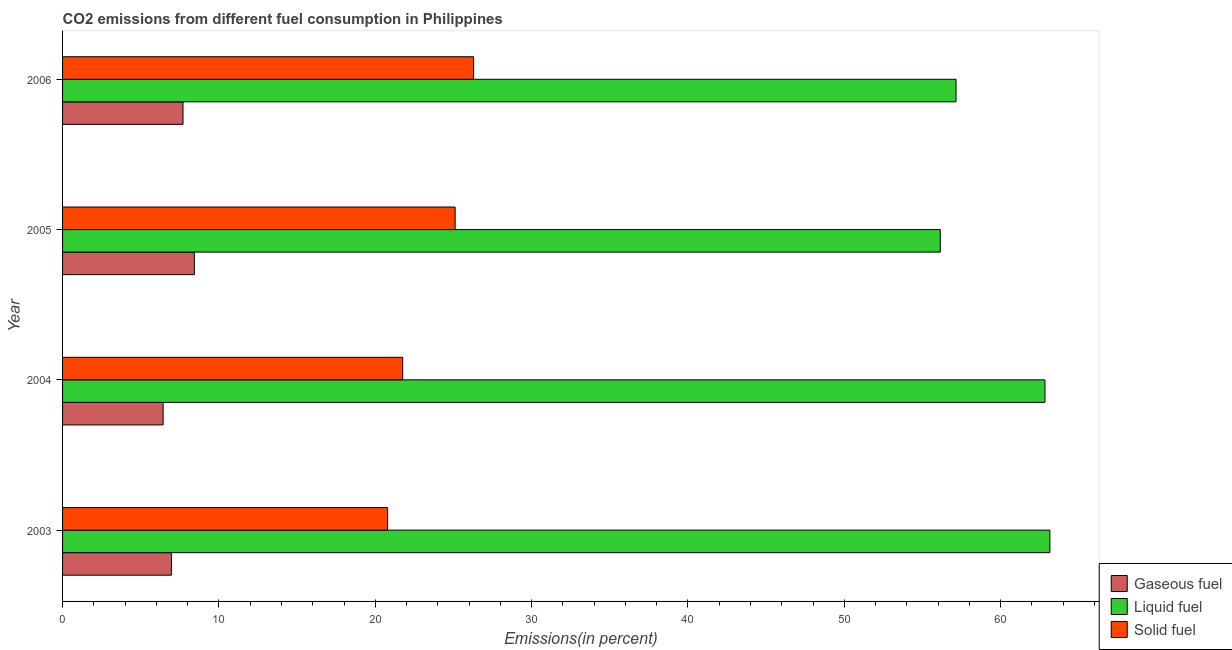How many different coloured bars are there?
Provide a short and direct response. 3. What is the percentage of solid fuel emission in 2004?
Give a very brief answer. 21.75. Across all years, what is the maximum percentage of solid fuel emission?
Keep it short and to the point. 26.29. Across all years, what is the minimum percentage of solid fuel emission?
Provide a succinct answer. 20.79. What is the total percentage of liquid fuel emission in the graph?
Your answer should be compact. 239.26. What is the difference between the percentage of gaseous fuel emission in 2005 and that in 2006?
Your response must be concise. 0.72. What is the difference between the percentage of liquid fuel emission in 2005 and the percentage of solid fuel emission in 2003?
Ensure brevity in your answer.  35.35. What is the average percentage of solid fuel emission per year?
Give a very brief answer. 23.48. In the year 2006, what is the difference between the percentage of gaseous fuel emission and percentage of solid fuel emission?
Your answer should be very brief. -18.59. What is the ratio of the percentage of gaseous fuel emission in 2004 to that in 2005?
Give a very brief answer. 0.76. What is the difference between the highest and the second highest percentage of solid fuel emission?
Give a very brief answer. 1.18. In how many years, is the percentage of liquid fuel emission greater than the average percentage of liquid fuel emission taken over all years?
Keep it short and to the point. 2. Is the sum of the percentage of liquid fuel emission in 2003 and 2005 greater than the maximum percentage of solid fuel emission across all years?
Offer a very short reply. Yes. What does the 3rd bar from the top in 2005 represents?
Ensure brevity in your answer.  Gaseous fuel. What does the 2nd bar from the bottom in 2006 represents?
Keep it short and to the point. Liquid fuel. Is it the case that in every year, the sum of the percentage of gaseous fuel emission and percentage of liquid fuel emission is greater than the percentage of solid fuel emission?
Offer a terse response. Yes. Are all the bars in the graph horizontal?
Provide a succinct answer. Yes. What is the difference between two consecutive major ticks on the X-axis?
Your answer should be very brief. 10. Does the graph contain any zero values?
Your answer should be very brief. No. How are the legend labels stacked?
Keep it short and to the point. Vertical. What is the title of the graph?
Give a very brief answer. CO2 emissions from different fuel consumption in Philippines. What is the label or title of the X-axis?
Offer a terse response. Emissions(in percent). What is the Emissions(in percent) of Gaseous fuel in 2003?
Provide a short and direct response. 6.96. What is the Emissions(in percent) in Liquid fuel in 2003?
Give a very brief answer. 63.15. What is the Emissions(in percent) in Solid fuel in 2003?
Your response must be concise. 20.79. What is the Emissions(in percent) of Gaseous fuel in 2004?
Make the answer very short. 6.43. What is the Emissions(in percent) of Liquid fuel in 2004?
Give a very brief answer. 62.83. What is the Emissions(in percent) of Solid fuel in 2004?
Keep it short and to the point. 21.75. What is the Emissions(in percent) in Gaseous fuel in 2005?
Offer a very short reply. 8.43. What is the Emissions(in percent) in Liquid fuel in 2005?
Make the answer very short. 56.14. What is the Emissions(in percent) in Solid fuel in 2005?
Keep it short and to the point. 25.11. What is the Emissions(in percent) of Gaseous fuel in 2006?
Keep it short and to the point. 7.7. What is the Emissions(in percent) of Liquid fuel in 2006?
Provide a short and direct response. 57.15. What is the Emissions(in percent) in Solid fuel in 2006?
Provide a succinct answer. 26.29. Across all years, what is the maximum Emissions(in percent) of Gaseous fuel?
Provide a succinct answer. 8.43. Across all years, what is the maximum Emissions(in percent) in Liquid fuel?
Make the answer very short. 63.15. Across all years, what is the maximum Emissions(in percent) in Solid fuel?
Give a very brief answer. 26.29. Across all years, what is the minimum Emissions(in percent) in Gaseous fuel?
Your answer should be compact. 6.43. Across all years, what is the minimum Emissions(in percent) in Liquid fuel?
Offer a very short reply. 56.14. Across all years, what is the minimum Emissions(in percent) in Solid fuel?
Provide a short and direct response. 20.79. What is the total Emissions(in percent) of Gaseous fuel in the graph?
Your answer should be very brief. 29.52. What is the total Emissions(in percent) in Liquid fuel in the graph?
Your answer should be compact. 239.26. What is the total Emissions(in percent) in Solid fuel in the graph?
Provide a short and direct response. 93.94. What is the difference between the Emissions(in percent) of Gaseous fuel in 2003 and that in 2004?
Provide a short and direct response. 0.53. What is the difference between the Emissions(in percent) of Liquid fuel in 2003 and that in 2004?
Provide a short and direct response. 0.31. What is the difference between the Emissions(in percent) in Solid fuel in 2003 and that in 2004?
Your response must be concise. -0.97. What is the difference between the Emissions(in percent) of Gaseous fuel in 2003 and that in 2005?
Your answer should be compact. -1.47. What is the difference between the Emissions(in percent) of Liquid fuel in 2003 and that in 2005?
Your answer should be compact. 7.01. What is the difference between the Emissions(in percent) of Solid fuel in 2003 and that in 2005?
Provide a succinct answer. -4.32. What is the difference between the Emissions(in percent) in Gaseous fuel in 2003 and that in 2006?
Ensure brevity in your answer.  -0.74. What is the difference between the Emissions(in percent) of Liquid fuel in 2003 and that in 2006?
Make the answer very short. 6. What is the difference between the Emissions(in percent) in Solid fuel in 2003 and that in 2006?
Give a very brief answer. -5.5. What is the difference between the Emissions(in percent) of Gaseous fuel in 2004 and that in 2005?
Offer a very short reply. -2. What is the difference between the Emissions(in percent) of Liquid fuel in 2004 and that in 2005?
Provide a succinct answer. 6.7. What is the difference between the Emissions(in percent) in Solid fuel in 2004 and that in 2005?
Give a very brief answer. -3.35. What is the difference between the Emissions(in percent) in Gaseous fuel in 2004 and that in 2006?
Give a very brief answer. -1.27. What is the difference between the Emissions(in percent) of Liquid fuel in 2004 and that in 2006?
Offer a terse response. 5.69. What is the difference between the Emissions(in percent) of Solid fuel in 2004 and that in 2006?
Your answer should be very brief. -4.53. What is the difference between the Emissions(in percent) in Gaseous fuel in 2005 and that in 2006?
Give a very brief answer. 0.73. What is the difference between the Emissions(in percent) of Liquid fuel in 2005 and that in 2006?
Make the answer very short. -1.01. What is the difference between the Emissions(in percent) in Solid fuel in 2005 and that in 2006?
Provide a succinct answer. -1.18. What is the difference between the Emissions(in percent) in Gaseous fuel in 2003 and the Emissions(in percent) in Liquid fuel in 2004?
Ensure brevity in your answer.  -55.87. What is the difference between the Emissions(in percent) in Gaseous fuel in 2003 and the Emissions(in percent) in Solid fuel in 2004?
Offer a terse response. -14.79. What is the difference between the Emissions(in percent) of Liquid fuel in 2003 and the Emissions(in percent) of Solid fuel in 2004?
Your response must be concise. 41.39. What is the difference between the Emissions(in percent) of Gaseous fuel in 2003 and the Emissions(in percent) of Liquid fuel in 2005?
Your response must be concise. -49.18. What is the difference between the Emissions(in percent) of Gaseous fuel in 2003 and the Emissions(in percent) of Solid fuel in 2005?
Make the answer very short. -18.15. What is the difference between the Emissions(in percent) of Liquid fuel in 2003 and the Emissions(in percent) of Solid fuel in 2005?
Your answer should be very brief. 38.04. What is the difference between the Emissions(in percent) of Gaseous fuel in 2003 and the Emissions(in percent) of Liquid fuel in 2006?
Provide a short and direct response. -50.18. What is the difference between the Emissions(in percent) in Gaseous fuel in 2003 and the Emissions(in percent) in Solid fuel in 2006?
Give a very brief answer. -19.33. What is the difference between the Emissions(in percent) of Liquid fuel in 2003 and the Emissions(in percent) of Solid fuel in 2006?
Ensure brevity in your answer.  36.86. What is the difference between the Emissions(in percent) in Gaseous fuel in 2004 and the Emissions(in percent) in Liquid fuel in 2005?
Ensure brevity in your answer.  -49.71. What is the difference between the Emissions(in percent) in Gaseous fuel in 2004 and the Emissions(in percent) in Solid fuel in 2005?
Ensure brevity in your answer.  -18.68. What is the difference between the Emissions(in percent) of Liquid fuel in 2004 and the Emissions(in percent) of Solid fuel in 2005?
Your answer should be very brief. 37.72. What is the difference between the Emissions(in percent) of Gaseous fuel in 2004 and the Emissions(in percent) of Liquid fuel in 2006?
Ensure brevity in your answer.  -50.71. What is the difference between the Emissions(in percent) in Gaseous fuel in 2004 and the Emissions(in percent) in Solid fuel in 2006?
Offer a terse response. -19.86. What is the difference between the Emissions(in percent) in Liquid fuel in 2004 and the Emissions(in percent) in Solid fuel in 2006?
Make the answer very short. 36.54. What is the difference between the Emissions(in percent) in Gaseous fuel in 2005 and the Emissions(in percent) in Liquid fuel in 2006?
Your response must be concise. -48.72. What is the difference between the Emissions(in percent) of Gaseous fuel in 2005 and the Emissions(in percent) of Solid fuel in 2006?
Provide a short and direct response. -17.86. What is the difference between the Emissions(in percent) of Liquid fuel in 2005 and the Emissions(in percent) of Solid fuel in 2006?
Your response must be concise. 29.85. What is the average Emissions(in percent) in Gaseous fuel per year?
Offer a very short reply. 7.38. What is the average Emissions(in percent) in Liquid fuel per year?
Your answer should be compact. 59.82. What is the average Emissions(in percent) of Solid fuel per year?
Offer a very short reply. 23.49. In the year 2003, what is the difference between the Emissions(in percent) of Gaseous fuel and Emissions(in percent) of Liquid fuel?
Offer a terse response. -56.19. In the year 2003, what is the difference between the Emissions(in percent) of Gaseous fuel and Emissions(in percent) of Solid fuel?
Your answer should be very brief. -13.83. In the year 2003, what is the difference between the Emissions(in percent) of Liquid fuel and Emissions(in percent) of Solid fuel?
Provide a succinct answer. 42.36. In the year 2004, what is the difference between the Emissions(in percent) of Gaseous fuel and Emissions(in percent) of Liquid fuel?
Provide a short and direct response. -56.4. In the year 2004, what is the difference between the Emissions(in percent) of Gaseous fuel and Emissions(in percent) of Solid fuel?
Give a very brief answer. -15.32. In the year 2004, what is the difference between the Emissions(in percent) in Liquid fuel and Emissions(in percent) in Solid fuel?
Offer a very short reply. 41.08. In the year 2005, what is the difference between the Emissions(in percent) of Gaseous fuel and Emissions(in percent) of Liquid fuel?
Make the answer very short. -47.71. In the year 2005, what is the difference between the Emissions(in percent) in Gaseous fuel and Emissions(in percent) in Solid fuel?
Provide a succinct answer. -16.68. In the year 2005, what is the difference between the Emissions(in percent) of Liquid fuel and Emissions(in percent) of Solid fuel?
Offer a very short reply. 31.03. In the year 2006, what is the difference between the Emissions(in percent) in Gaseous fuel and Emissions(in percent) in Liquid fuel?
Offer a terse response. -49.44. In the year 2006, what is the difference between the Emissions(in percent) of Gaseous fuel and Emissions(in percent) of Solid fuel?
Your response must be concise. -18.59. In the year 2006, what is the difference between the Emissions(in percent) of Liquid fuel and Emissions(in percent) of Solid fuel?
Your answer should be very brief. 30.86. What is the ratio of the Emissions(in percent) in Gaseous fuel in 2003 to that in 2004?
Offer a terse response. 1.08. What is the ratio of the Emissions(in percent) of Liquid fuel in 2003 to that in 2004?
Give a very brief answer. 1. What is the ratio of the Emissions(in percent) in Solid fuel in 2003 to that in 2004?
Offer a very short reply. 0.96. What is the ratio of the Emissions(in percent) of Gaseous fuel in 2003 to that in 2005?
Your answer should be compact. 0.83. What is the ratio of the Emissions(in percent) in Liquid fuel in 2003 to that in 2005?
Keep it short and to the point. 1.12. What is the ratio of the Emissions(in percent) in Solid fuel in 2003 to that in 2005?
Your answer should be very brief. 0.83. What is the ratio of the Emissions(in percent) in Gaseous fuel in 2003 to that in 2006?
Give a very brief answer. 0.9. What is the ratio of the Emissions(in percent) of Liquid fuel in 2003 to that in 2006?
Keep it short and to the point. 1.1. What is the ratio of the Emissions(in percent) of Solid fuel in 2003 to that in 2006?
Your response must be concise. 0.79. What is the ratio of the Emissions(in percent) in Gaseous fuel in 2004 to that in 2005?
Provide a succinct answer. 0.76. What is the ratio of the Emissions(in percent) in Liquid fuel in 2004 to that in 2005?
Provide a short and direct response. 1.12. What is the ratio of the Emissions(in percent) in Solid fuel in 2004 to that in 2005?
Make the answer very short. 0.87. What is the ratio of the Emissions(in percent) of Gaseous fuel in 2004 to that in 2006?
Provide a succinct answer. 0.83. What is the ratio of the Emissions(in percent) in Liquid fuel in 2004 to that in 2006?
Keep it short and to the point. 1.1. What is the ratio of the Emissions(in percent) in Solid fuel in 2004 to that in 2006?
Your answer should be very brief. 0.83. What is the ratio of the Emissions(in percent) of Gaseous fuel in 2005 to that in 2006?
Your answer should be compact. 1.09. What is the ratio of the Emissions(in percent) in Liquid fuel in 2005 to that in 2006?
Offer a very short reply. 0.98. What is the ratio of the Emissions(in percent) of Solid fuel in 2005 to that in 2006?
Make the answer very short. 0.96. What is the difference between the highest and the second highest Emissions(in percent) of Gaseous fuel?
Provide a succinct answer. 0.73. What is the difference between the highest and the second highest Emissions(in percent) of Liquid fuel?
Make the answer very short. 0.31. What is the difference between the highest and the second highest Emissions(in percent) of Solid fuel?
Your answer should be very brief. 1.18. What is the difference between the highest and the lowest Emissions(in percent) of Gaseous fuel?
Keep it short and to the point. 2. What is the difference between the highest and the lowest Emissions(in percent) of Liquid fuel?
Provide a succinct answer. 7.01. What is the difference between the highest and the lowest Emissions(in percent) of Solid fuel?
Offer a terse response. 5.5. 